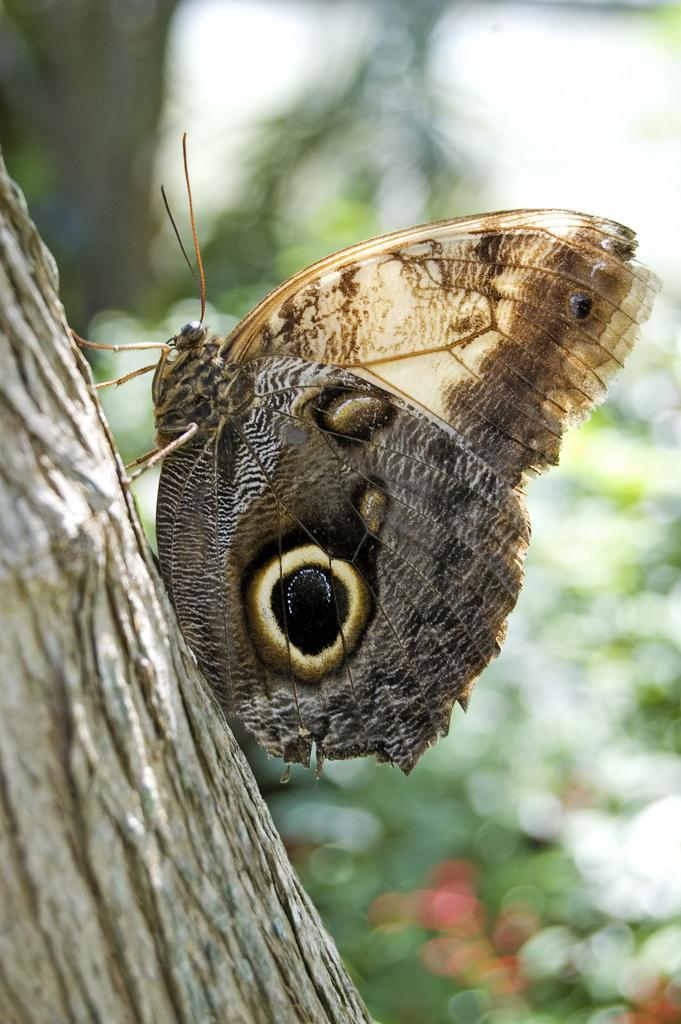What is the main subject of the image? The main subject of the image is a butterfly. Where is the butterfly located in the image? The butterfly is on the trunk of a tree. Can you describe the background of the image? The background of the image is blurred. What type of request can be seen being made by the butterfly in the image? There is no request visible in the image, as it features a butterfly on a tree trunk. What color is the gold expansion pack in the image? There is no gold expansion pack present in the image. 